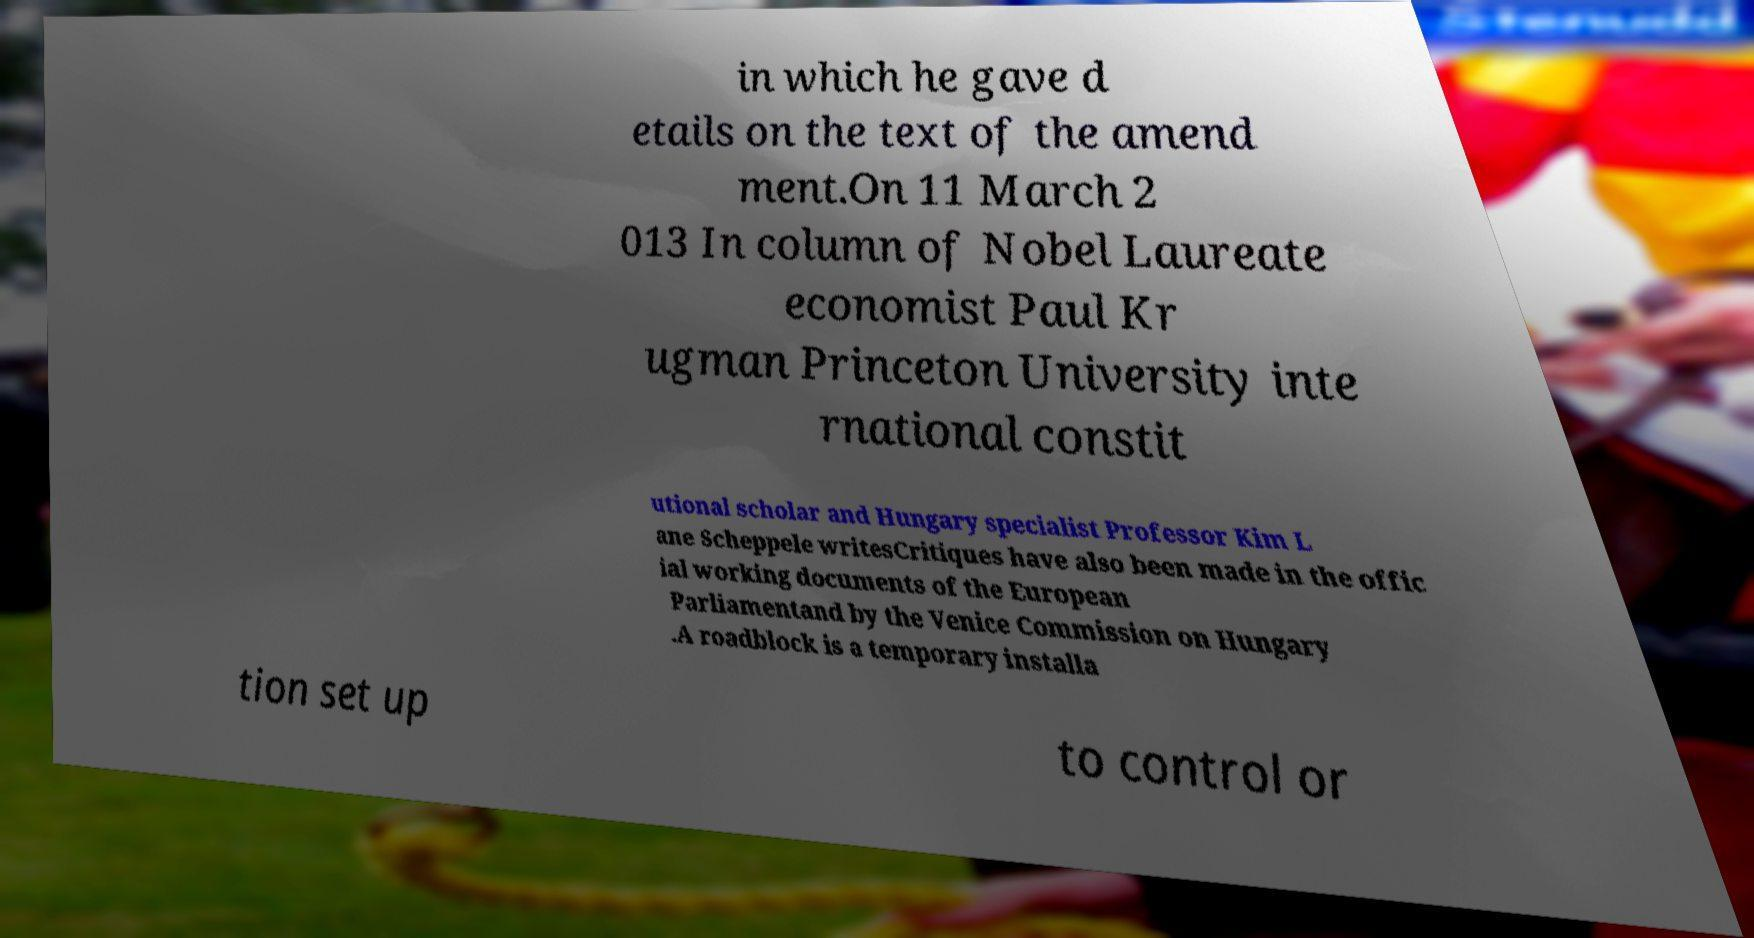Can you accurately transcribe the text from the provided image for me? in which he gave d etails on the text of the amend ment.On 11 March 2 013 In column of Nobel Laureate economist Paul Kr ugman Princeton University inte rnational constit utional scholar and Hungary specialist Professor Kim L ane Scheppele writesCritiques have also been made in the offic ial working documents of the European Parliamentand by the Venice Commission on Hungary .A roadblock is a temporary installa tion set up to control or 